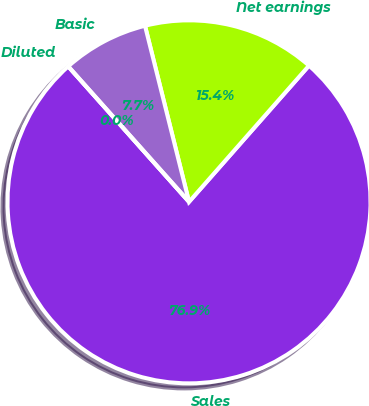Convert chart. <chart><loc_0><loc_0><loc_500><loc_500><pie_chart><fcel>Sales<fcel>Net earnings<fcel>Basic<fcel>Diluted<nl><fcel>76.92%<fcel>15.39%<fcel>7.69%<fcel>0.0%<nl></chart> 